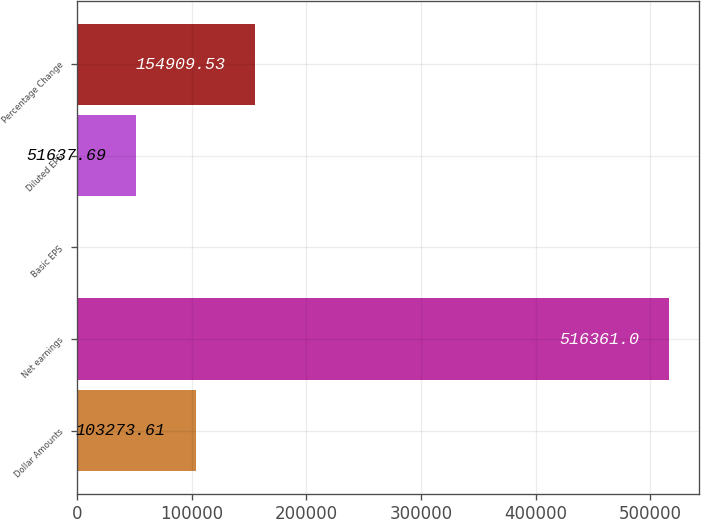<chart> <loc_0><loc_0><loc_500><loc_500><bar_chart><fcel>Dollar Amounts<fcel>Net earnings<fcel>Basic EPS<fcel>Diluted EPS<fcel>Percentage Change<nl><fcel>103274<fcel>516361<fcel>1.77<fcel>51637.7<fcel>154910<nl></chart> 